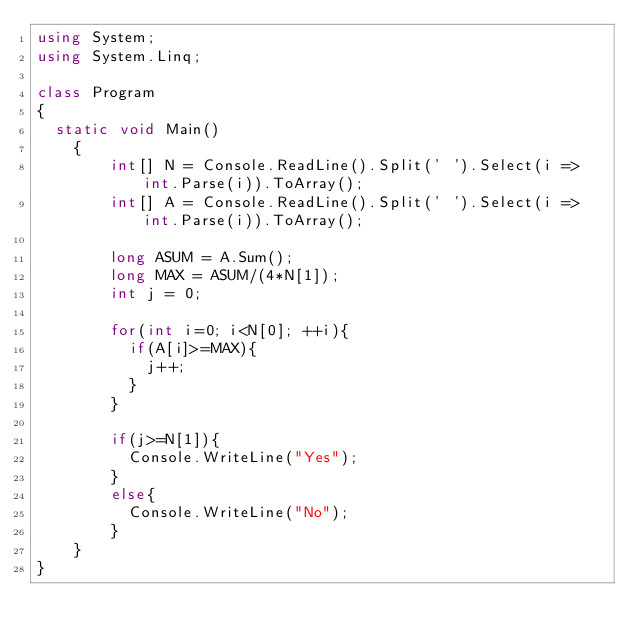<code> <loc_0><loc_0><loc_500><loc_500><_C#_>using System;
using System.Linq;

class Program
{
	static void Main()
    {
      	int[] N = Console.ReadLine().Split(' ').Select(i => int.Parse(i)).ToArray();
        int[] A = Console.ReadLine().Split(' ').Select(i => int.Parse(i)).ToArray();
		
      	long ASUM = A.Sum();
      	long MAX = ASUM/(4*N[1]);
      	int j = 0; 
      
      	for(int i=0; i<N[0]; ++i){
          if(A[i]>=MAX){
            j++;
          }
        }
      
      	if(j>=N[1]){
          Console.WriteLine("Yes");
        }
      	else{
          Console.WriteLine("No");
        }
    }
}</code> 